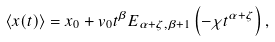<formula> <loc_0><loc_0><loc_500><loc_500>\left \langle x ( t ) \right \rangle = x _ { 0 } + v _ { 0 } t ^ { \beta } E _ { \alpha + \zeta , \beta + 1 } \left ( - \chi t ^ { \alpha + \zeta } \right ) ,</formula> 